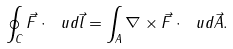Convert formula to latex. <formula><loc_0><loc_0><loc_500><loc_500>\oint _ { C } \vec { F } \cdot \ u d \vec { l } = \int _ { A } \nabla \times \vec { F } \cdot \ u d \vec { A } .</formula> 